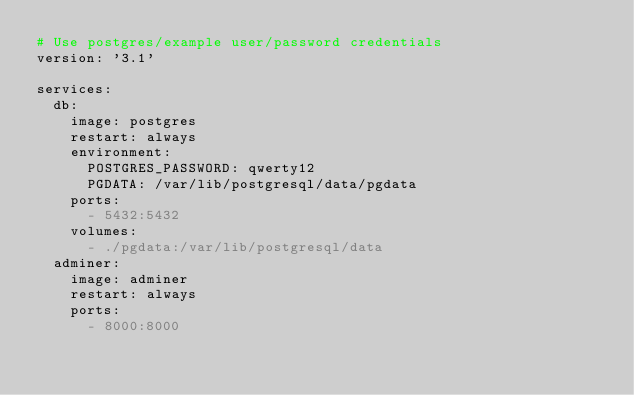<code> <loc_0><loc_0><loc_500><loc_500><_YAML_># Use postgres/example user/password credentials
version: '3.1'

services:
  db:
    image: postgres
    restart: always
    environment:
      POSTGRES_PASSWORD: qwerty12
      PGDATA: /var/lib/postgresql/data/pgdata
    ports:
      - 5432:5432
    volumes:
      - ./pgdata:/var/lib/postgresql/data
  adminer:
    image: adminer
    restart: always
    ports:
      - 8000:8000
</code> 